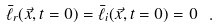<formula> <loc_0><loc_0><loc_500><loc_500>\bar { \ell } _ { r } ( \vec { x } , t = 0 ) = \bar { \ell } _ { i } ( \vec { x } , t = 0 ) = 0 \ .</formula> 